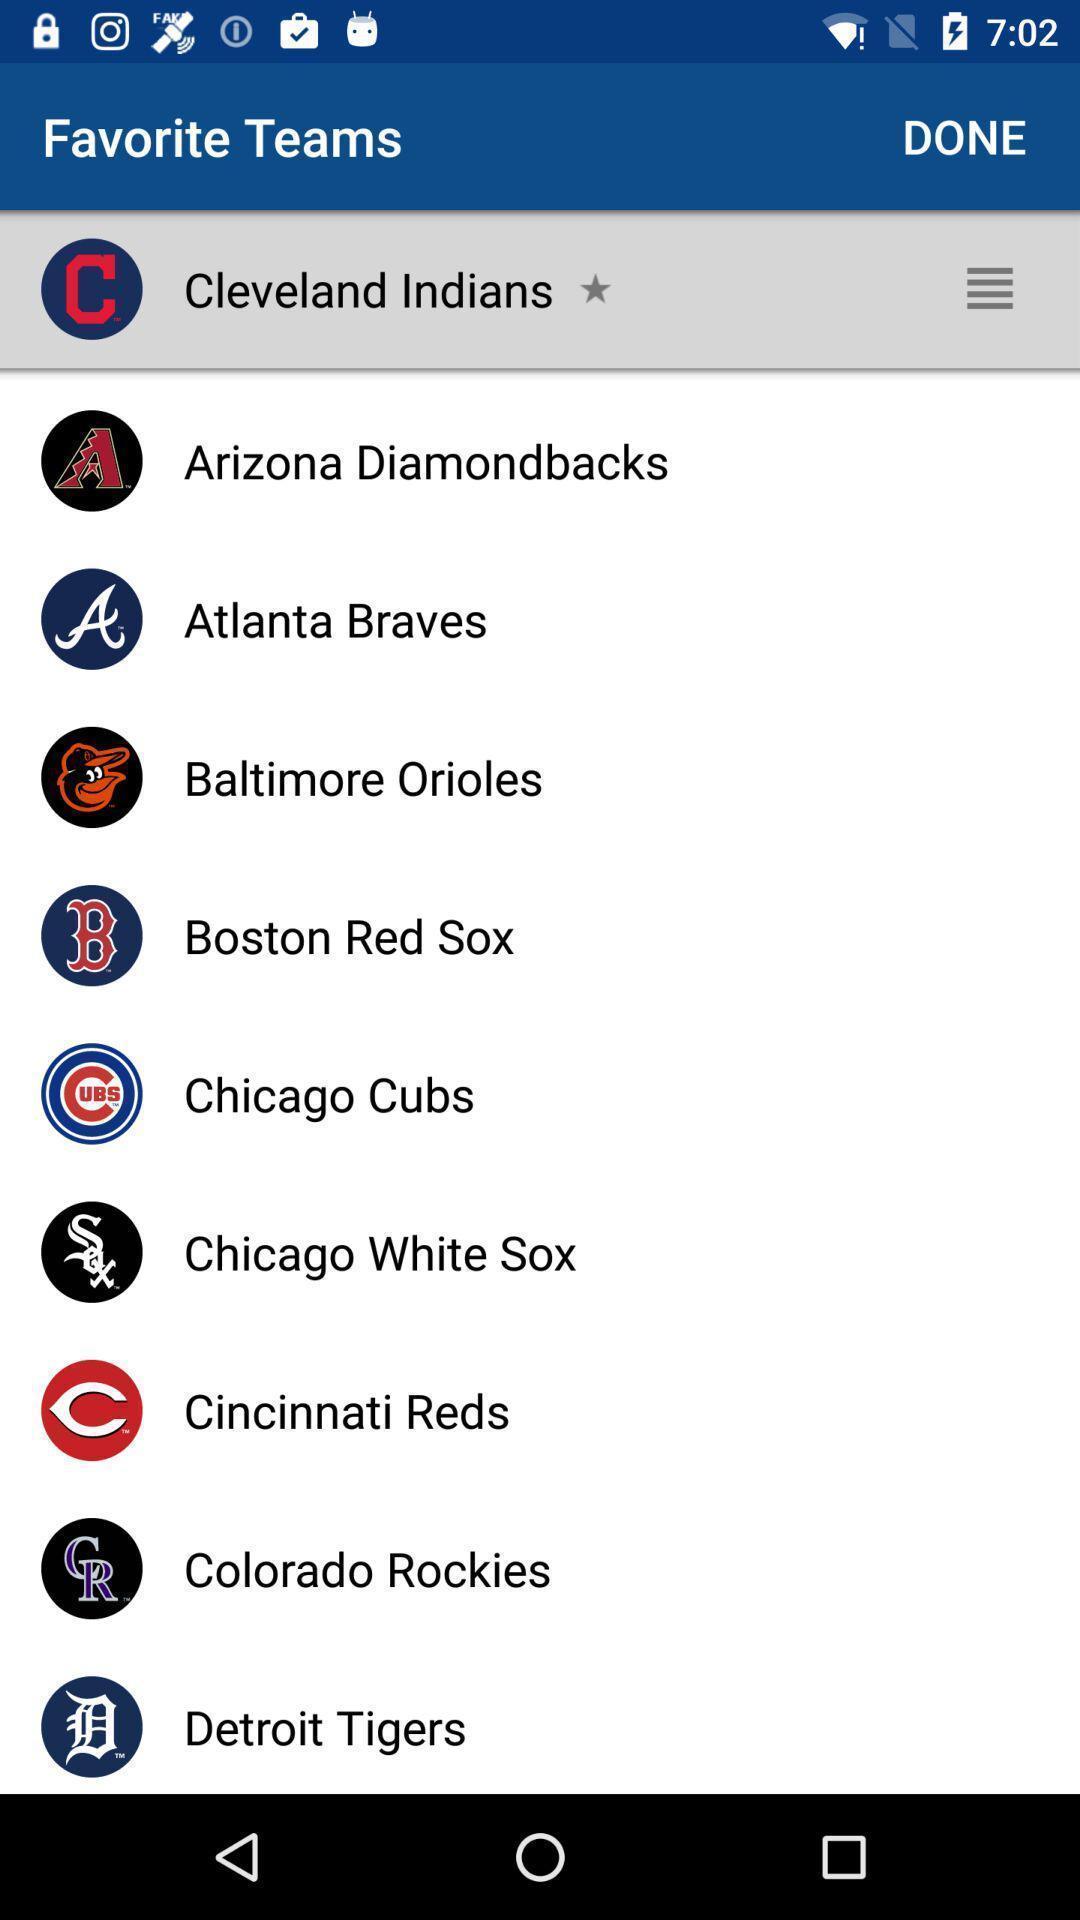Tell me about the visual elements in this screen capture. Page displaying various information in sports application. 